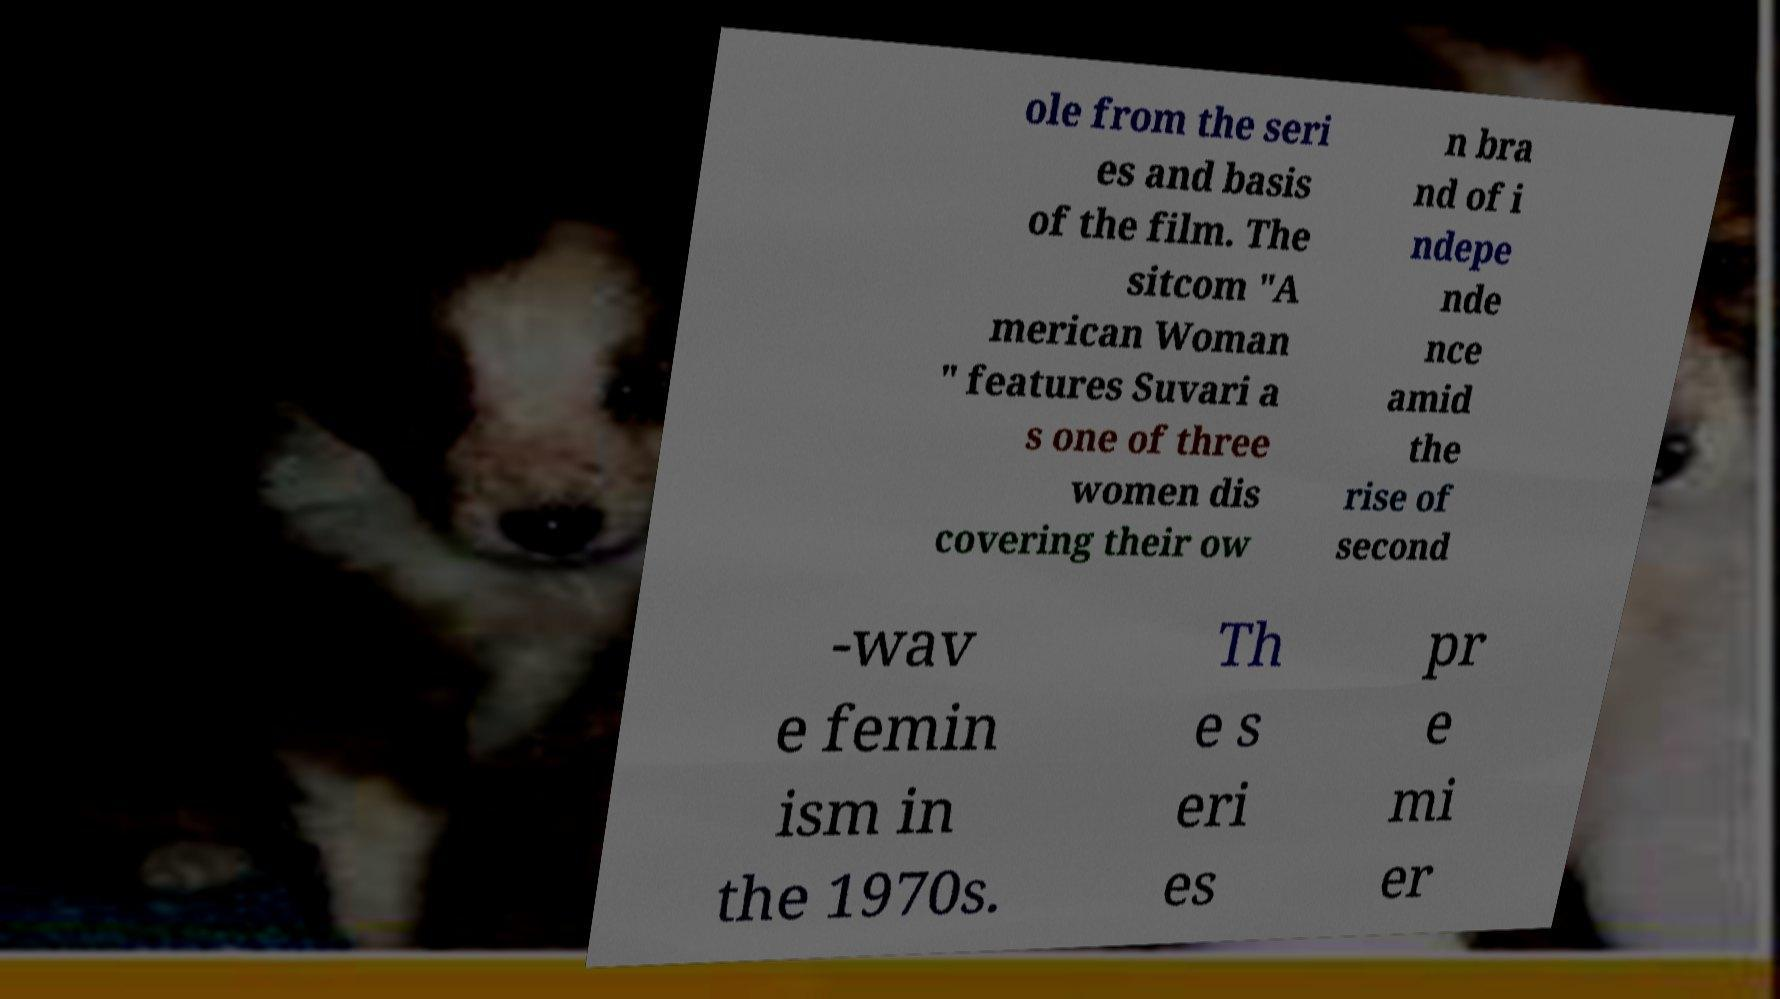Please identify and transcribe the text found in this image. ole from the seri es and basis of the film. The sitcom "A merican Woman " features Suvari a s one of three women dis covering their ow n bra nd of i ndepe nde nce amid the rise of second -wav e femin ism in the 1970s. Th e s eri es pr e mi er 